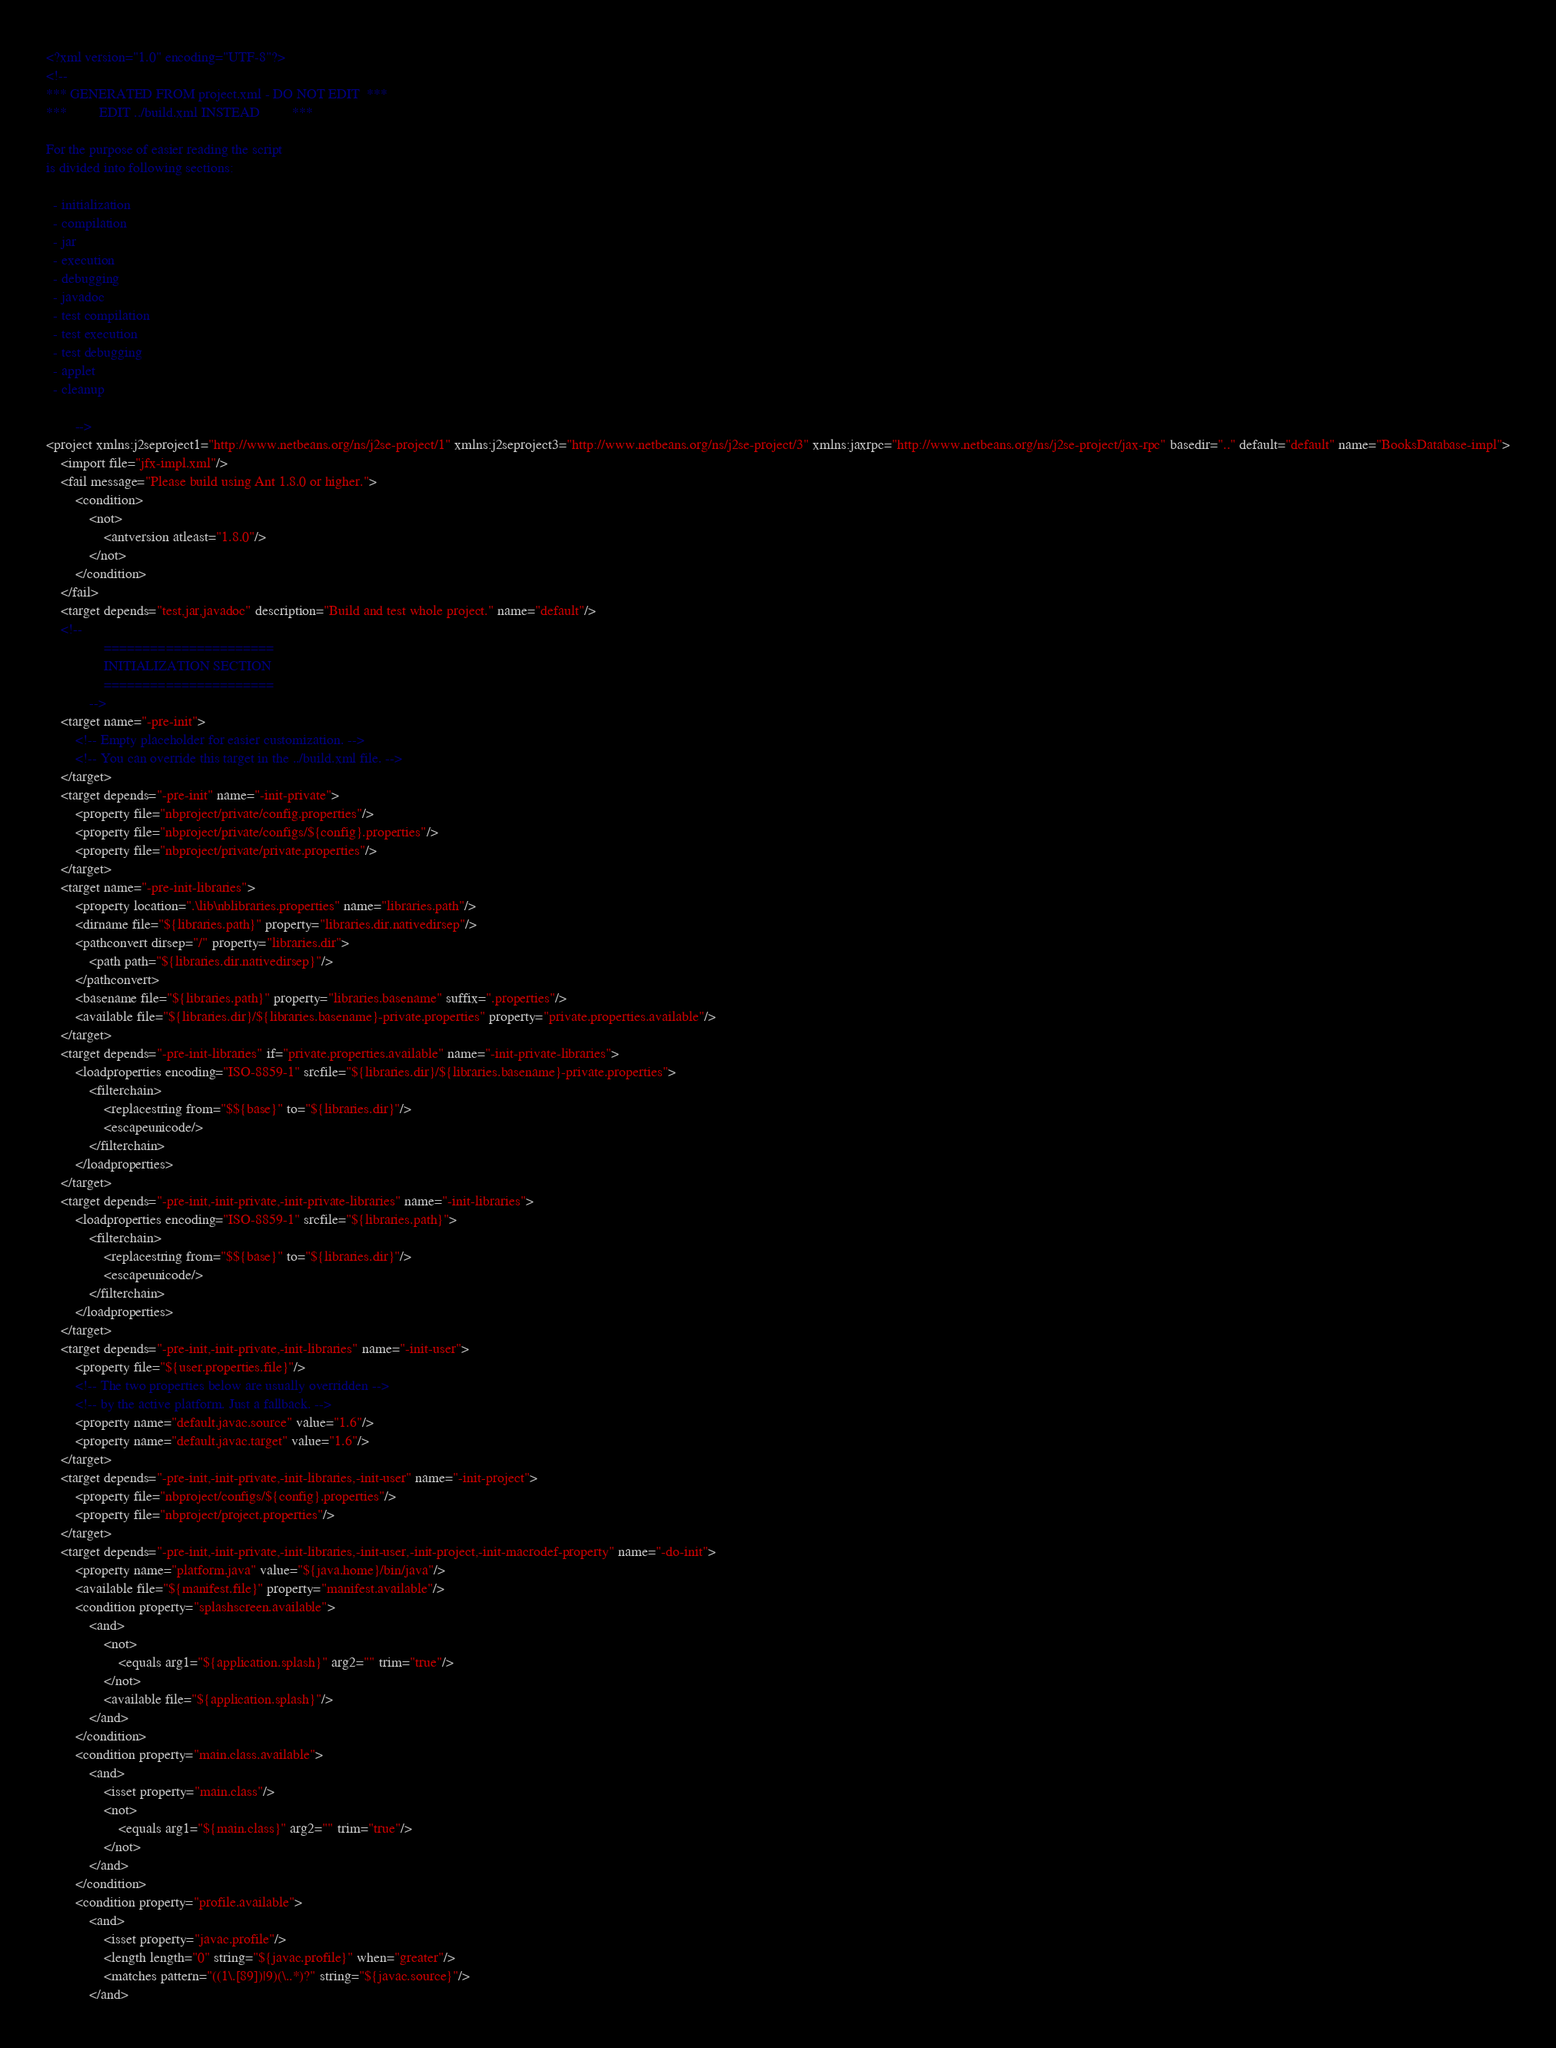Convert code to text. <code><loc_0><loc_0><loc_500><loc_500><_XML_><?xml version="1.0" encoding="UTF-8"?>
<!--
*** GENERATED FROM project.xml - DO NOT EDIT  ***
***         EDIT ../build.xml INSTEAD         ***

For the purpose of easier reading the script
is divided into following sections:

  - initialization
  - compilation
  - jar
  - execution
  - debugging
  - javadoc
  - test compilation
  - test execution
  - test debugging
  - applet
  - cleanup

        -->
<project xmlns:j2seproject1="http://www.netbeans.org/ns/j2se-project/1" xmlns:j2seproject3="http://www.netbeans.org/ns/j2se-project/3" xmlns:jaxrpc="http://www.netbeans.org/ns/j2se-project/jax-rpc" basedir=".." default="default" name="BooksDatabase-impl">
    <import file="jfx-impl.xml"/>
    <fail message="Please build using Ant 1.8.0 or higher.">
        <condition>
            <not>
                <antversion atleast="1.8.0"/>
            </not>
        </condition>
    </fail>
    <target depends="test,jar,javadoc" description="Build and test whole project." name="default"/>
    <!-- 
                ======================
                INITIALIZATION SECTION 
                ======================
            -->
    <target name="-pre-init">
        <!-- Empty placeholder for easier customization. -->
        <!-- You can override this target in the ../build.xml file. -->
    </target>
    <target depends="-pre-init" name="-init-private">
        <property file="nbproject/private/config.properties"/>
        <property file="nbproject/private/configs/${config}.properties"/>
        <property file="nbproject/private/private.properties"/>
    </target>
    <target name="-pre-init-libraries">
        <property location=".\lib\nblibraries.properties" name="libraries.path"/>
        <dirname file="${libraries.path}" property="libraries.dir.nativedirsep"/>
        <pathconvert dirsep="/" property="libraries.dir">
            <path path="${libraries.dir.nativedirsep}"/>
        </pathconvert>
        <basename file="${libraries.path}" property="libraries.basename" suffix=".properties"/>
        <available file="${libraries.dir}/${libraries.basename}-private.properties" property="private.properties.available"/>
    </target>
    <target depends="-pre-init-libraries" if="private.properties.available" name="-init-private-libraries">
        <loadproperties encoding="ISO-8859-1" srcfile="${libraries.dir}/${libraries.basename}-private.properties">
            <filterchain>
                <replacestring from="$${base}" to="${libraries.dir}"/>
                <escapeunicode/>
            </filterchain>
        </loadproperties>
    </target>
    <target depends="-pre-init,-init-private,-init-private-libraries" name="-init-libraries">
        <loadproperties encoding="ISO-8859-1" srcfile="${libraries.path}">
            <filterchain>
                <replacestring from="$${base}" to="${libraries.dir}"/>
                <escapeunicode/>
            </filterchain>
        </loadproperties>
    </target>
    <target depends="-pre-init,-init-private,-init-libraries" name="-init-user">
        <property file="${user.properties.file}"/>
        <!-- The two properties below are usually overridden -->
        <!-- by the active platform. Just a fallback. -->
        <property name="default.javac.source" value="1.6"/>
        <property name="default.javac.target" value="1.6"/>
    </target>
    <target depends="-pre-init,-init-private,-init-libraries,-init-user" name="-init-project">
        <property file="nbproject/configs/${config}.properties"/>
        <property file="nbproject/project.properties"/>
    </target>
    <target depends="-pre-init,-init-private,-init-libraries,-init-user,-init-project,-init-macrodef-property" name="-do-init">
        <property name="platform.java" value="${java.home}/bin/java"/>
        <available file="${manifest.file}" property="manifest.available"/>
        <condition property="splashscreen.available">
            <and>
                <not>
                    <equals arg1="${application.splash}" arg2="" trim="true"/>
                </not>
                <available file="${application.splash}"/>
            </and>
        </condition>
        <condition property="main.class.available">
            <and>
                <isset property="main.class"/>
                <not>
                    <equals arg1="${main.class}" arg2="" trim="true"/>
                </not>
            </and>
        </condition>
        <condition property="profile.available">
            <and>
                <isset property="javac.profile"/>
                <length length="0" string="${javac.profile}" when="greater"/>
                <matches pattern="((1\.[89])|9)(\..*)?" string="${javac.source}"/>
            </and></code> 